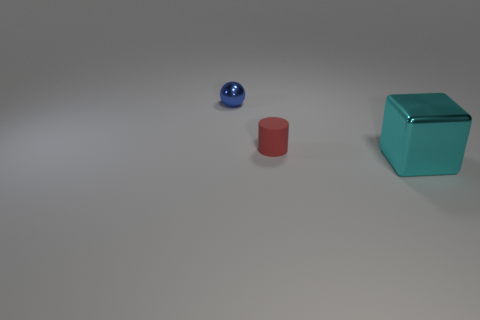Add 3 large cyan objects. How many objects exist? 6 Add 2 blue rubber things. How many blue rubber things exist? 2 Subtract 0 red spheres. How many objects are left? 3 Subtract all balls. How many objects are left? 2 Subtract all purple balls. Subtract all cyan blocks. How many balls are left? 1 Subtract all tiny matte balls. Subtract all red matte cylinders. How many objects are left? 2 Add 1 cyan metal cubes. How many cyan metal cubes are left? 2 